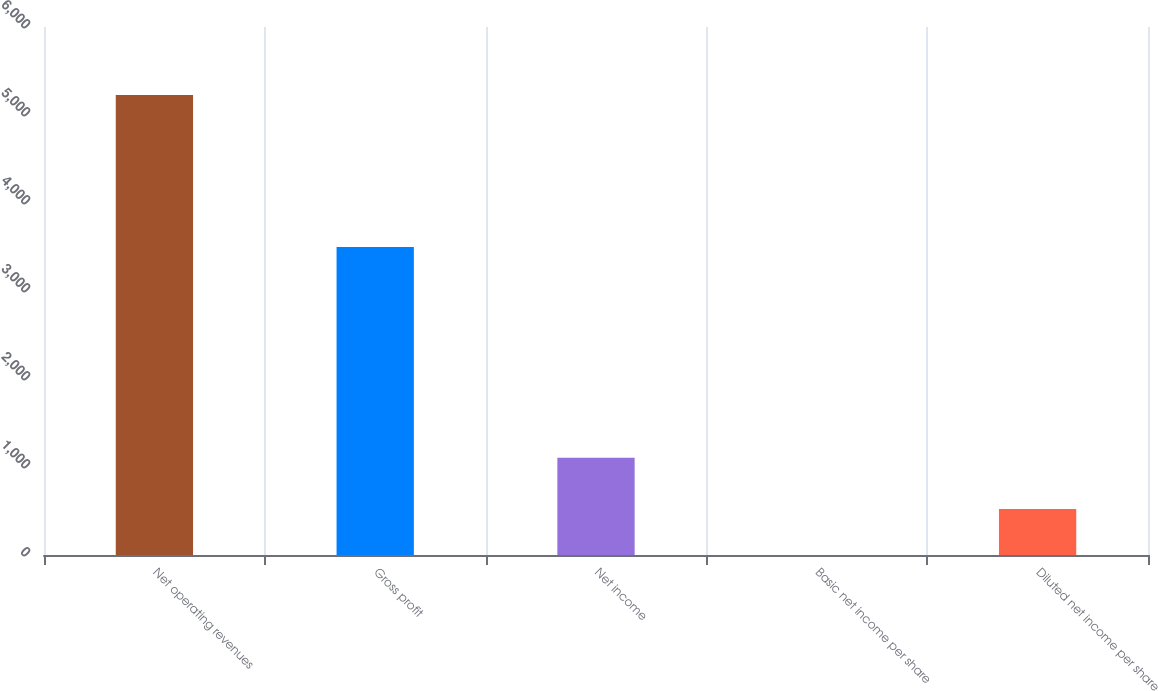Convert chart to OTSL. <chart><loc_0><loc_0><loc_500><loc_500><bar_chart><fcel>Net operating revenues<fcel>Gross profit<fcel>Net income<fcel>Basic net income per share<fcel>Diluted net income per share<nl><fcel>5226<fcel>3500<fcel>1106<fcel>0.47<fcel>523.02<nl></chart> 